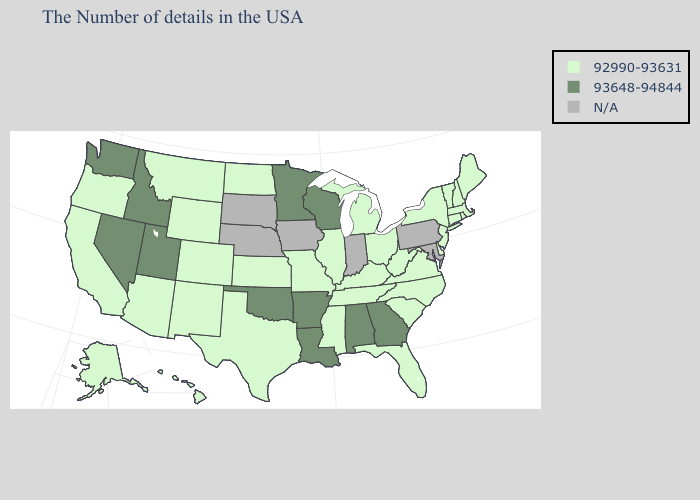Name the states that have a value in the range 92990-93631?
Answer briefly. Maine, Massachusetts, Rhode Island, New Hampshire, Vermont, Connecticut, New York, New Jersey, Delaware, Virginia, North Carolina, South Carolina, West Virginia, Ohio, Florida, Michigan, Kentucky, Tennessee, Illinois, Mississippi, Missouri, Kansas, Texas, North Dakota, Wyoming, Colorado, New Mexico, Montana, Arizona, California, Oregon, Alaska, Hawaii. Name the states that have a value in the range 92990-93631?
Short answer required. Maine, Massachusetts, Rhode Island, New Hampshire, Vermont, Connecticut, New York, New Jersey, Delaware, Virginia, North Carolina, South Carolina, West Virginia, Ohio, Florida, Michigan, Kentucky, Tennessee, Illinois, Mississippi, Missouri, Kansas, Texas, North Dakota, Wyoming, Colorado, New Mexico, Montana, Arizona, California, Oregon, Alaska, Hawaii. Name the states that have a value in the range 92990-93631?
Answer briefly. Maine, Massachusetts, Rhode Island, New Hampshire, Vermont, Connecticut, New York, New Jersey, Delaware, Virginia, North Carolina, South Carolina, West Virginia, Ohio, Florida, Michigan, Kentucky, Tennessee, Illinois, Mississippi, Missouri, Kansas, Texas, North Dakota, Wyoming, Colorado, New Mexico, Montana, Arizona, California, Oregon, Alaska, Hawaii. Name the states that have a value in the range N/A?
Be succinct. Maryland, Pennsylvania, Indiana, Iowa, Nebraska, South Dakota. What is the value of Hawaii?
Be succinct. 92990-93631. What is the highest value in states that border New Mexico?
Answer briefly. 93648-94844. What is the highest value in the USA?
Be succinct. 93648-94844. What is the value of Georgia?
Short answer required. 93648-94844. Does Louisiana have the lowest value in the South?
Keep it brief. No. Name the states that have a value in the range 93648-94844?
Quick response, please. Georgia, Alabama, Wisconsin, Louisiana, Arkansas, Minnesota, Oklahoma, Utah, Idaho, Nevada, Washington. Among the states that border Oregon , does California have the highest value?
Keep it brief. No. Name the states that have a value in the range 93648-94844?
Be succinct. Georgia, Alabama, Wisconsin, Louisiana, Arkansas, Minnesota, Oklahoma, Utah, Idaho, Nevada, Washington. How many symbols are there in the legend?
Be succinct. 3. 